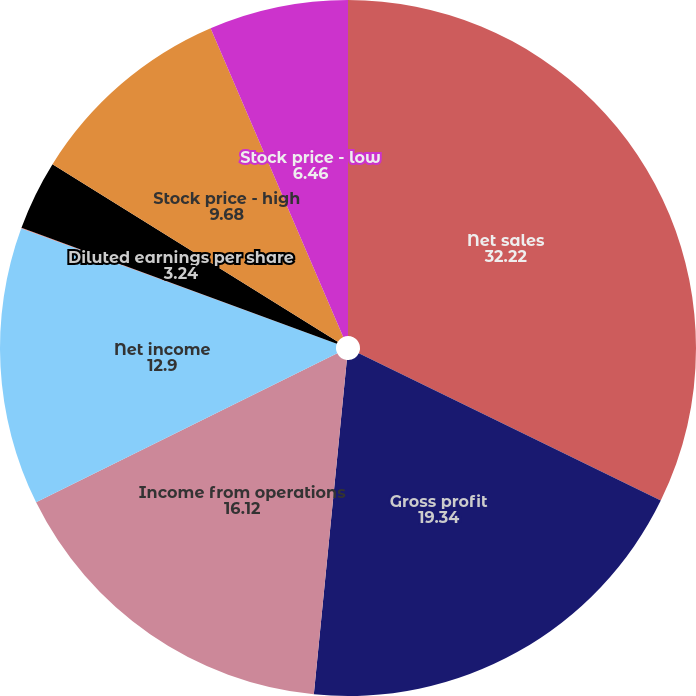Convert chart to OTSL. <chart><loc_0><loc_0><loc_500><loc_500><pie_chart><fcel>Net sales<fcel>Gross profit<fcel>Income from operations<fcel>Net income<fcel>Basic earnings per share<fcel>Diluted earnings per share<fcel>Stock price - high<fcel>Stock price - low<nl><fcel>32.22%<fcel>19.34%<fcel>16.12%<fcel>12.9%<fcel>0.03%<fcel>3.24%<fcel>9.68%<fcel>6.46%<nl></chart> 